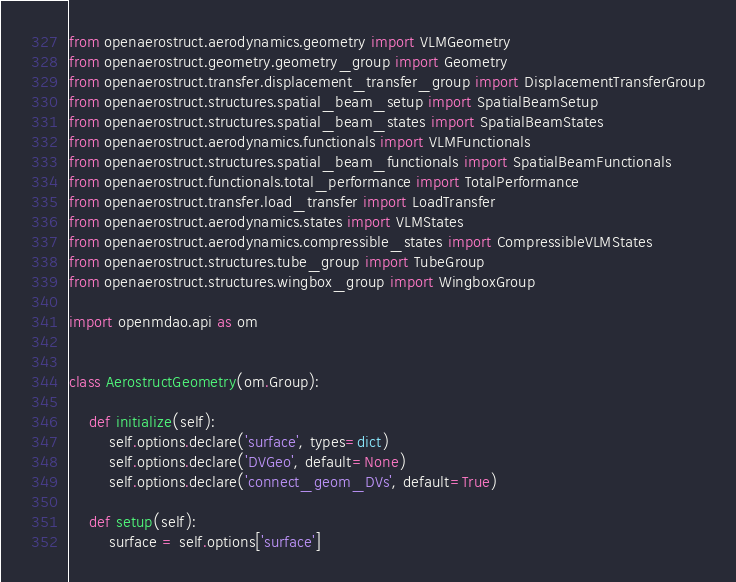Convert code to text. <code><loc_0><loc_0><loc_500><loc_500><_Python_>from openaerostruct.aerodynamics.geometry import VLMGeometry
from openaerostruct.geometry.geometry_group import Geometry
from openaerostruct.transfer.displacement_transfer_group import DisplacementTransferGroup
from openaerostruct.structures.spatial_beam_setup import SpatialBeamSetup
from openaerostruct.structures.spatial_beam_states import SpatialBeamStates
from openaerostruct.aerodynamics.functionals import VLMFunctionals
from openaerostruct.structures.spatial_beam_functionals import SpatialBeamFunctionals
from openaerostruct.functionals.total_performance import TotalPerformance
from openaerostruct.transfer.load_transfer import LoadTransfer
from openaerostruct.aerodynamics.states import VLMStates
from openaerostruct.aerodynamics.compressible_states import CompressibleVLMStates
from openaerostruct.structures.tube_group import TubeGroup
from openaerostruct.structures.wingbox_group import WingboxGroup

import openmdao.api as om


class AerostructGeometry(om.Group):

    def initialize(self):
        self.options.declare('surface', types=dict)
        self.options.declare('DVGeo', default=None)
        self.options.declare('connect_geom_DVs', default=True)

    def setup(self):
        surface = self.options['surface']</code> 